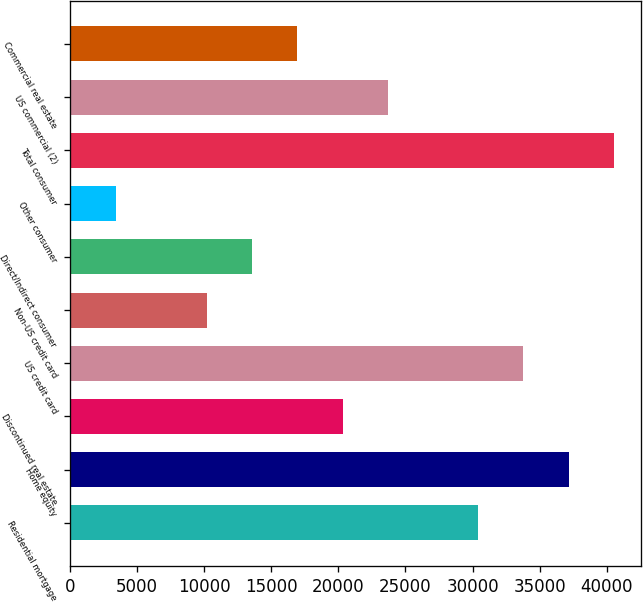Convert chart. <chart><loc_0><loc_0><loc_500><loc_500><bar_chart><fcel>Residential mortgage<fcel>Home equity<fcel>Discontinued real estate<fcel>US credit card<fcel>Non-US credit card<fcel>Direct/Indirect consumer<fcel>Other consumer<fcel>Total consumer<fcel>US commercial (2)<fcel>Commercial real estate<nl><fcel>30413.9<fcel>37152.1<fcel>20306.6<fcel>33783<fcel>10199.3<fcel>13568.4<fcel>3461.1<fcel>40521.2<fcel>23675.7<fcel>16937.5<nl></chart> 